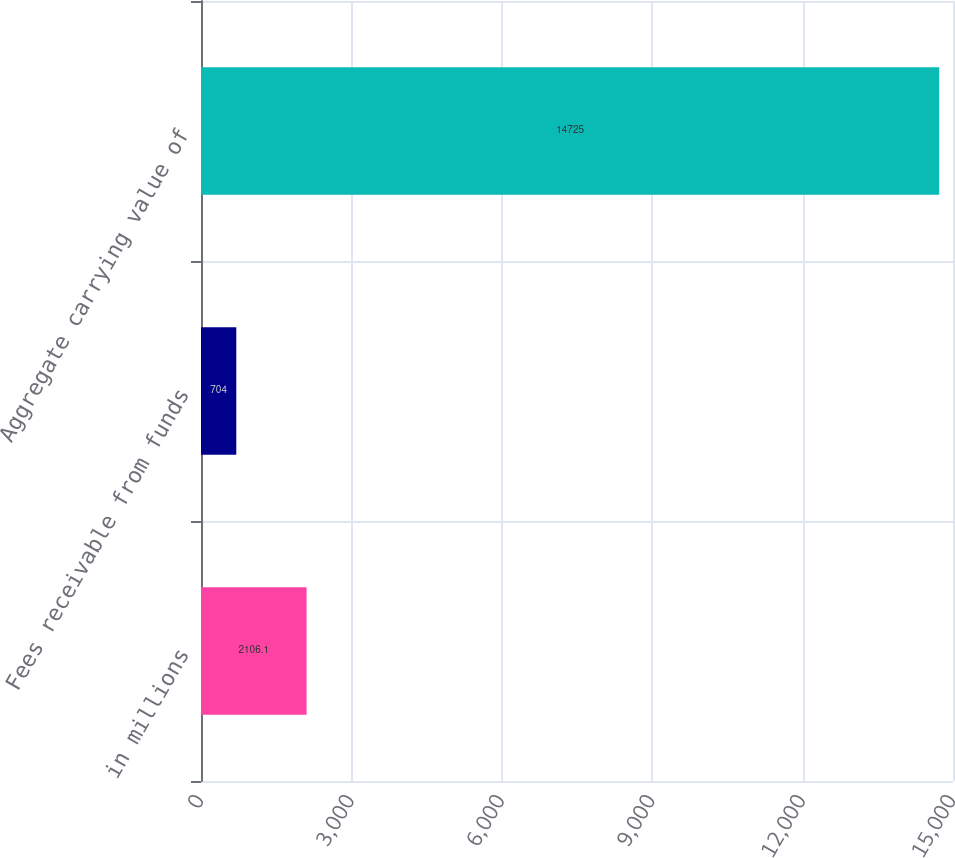<chart> <loc_0><loc_0><loc_500><loc_500><bar_chart><fcel>in millions<fcel>Fees receivable from funds<fcel>Aggregate carrying value of<nl><fcel>2106.1<fcel>704<fcel>14725<nl></chart> 